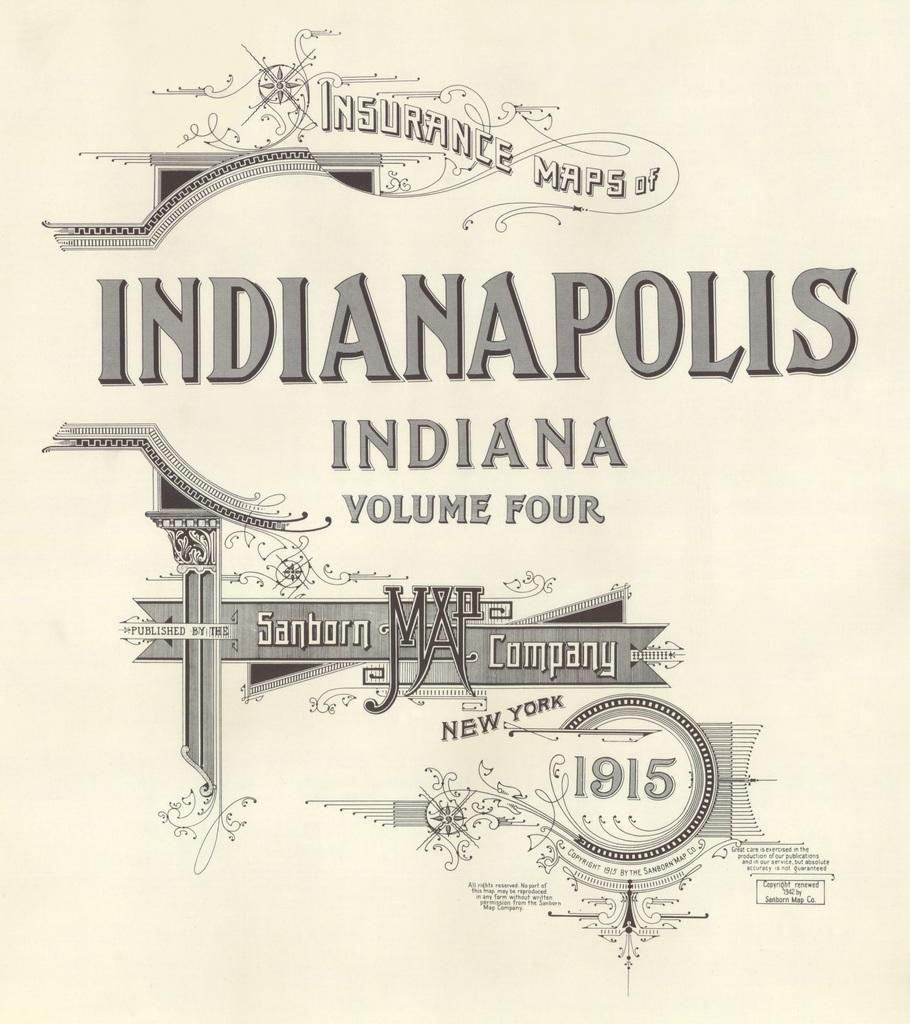<image>
Summarize the visual content of the image. Insurance maps of Indianapolis Indiana volume four by the Sanborn Map Company. 